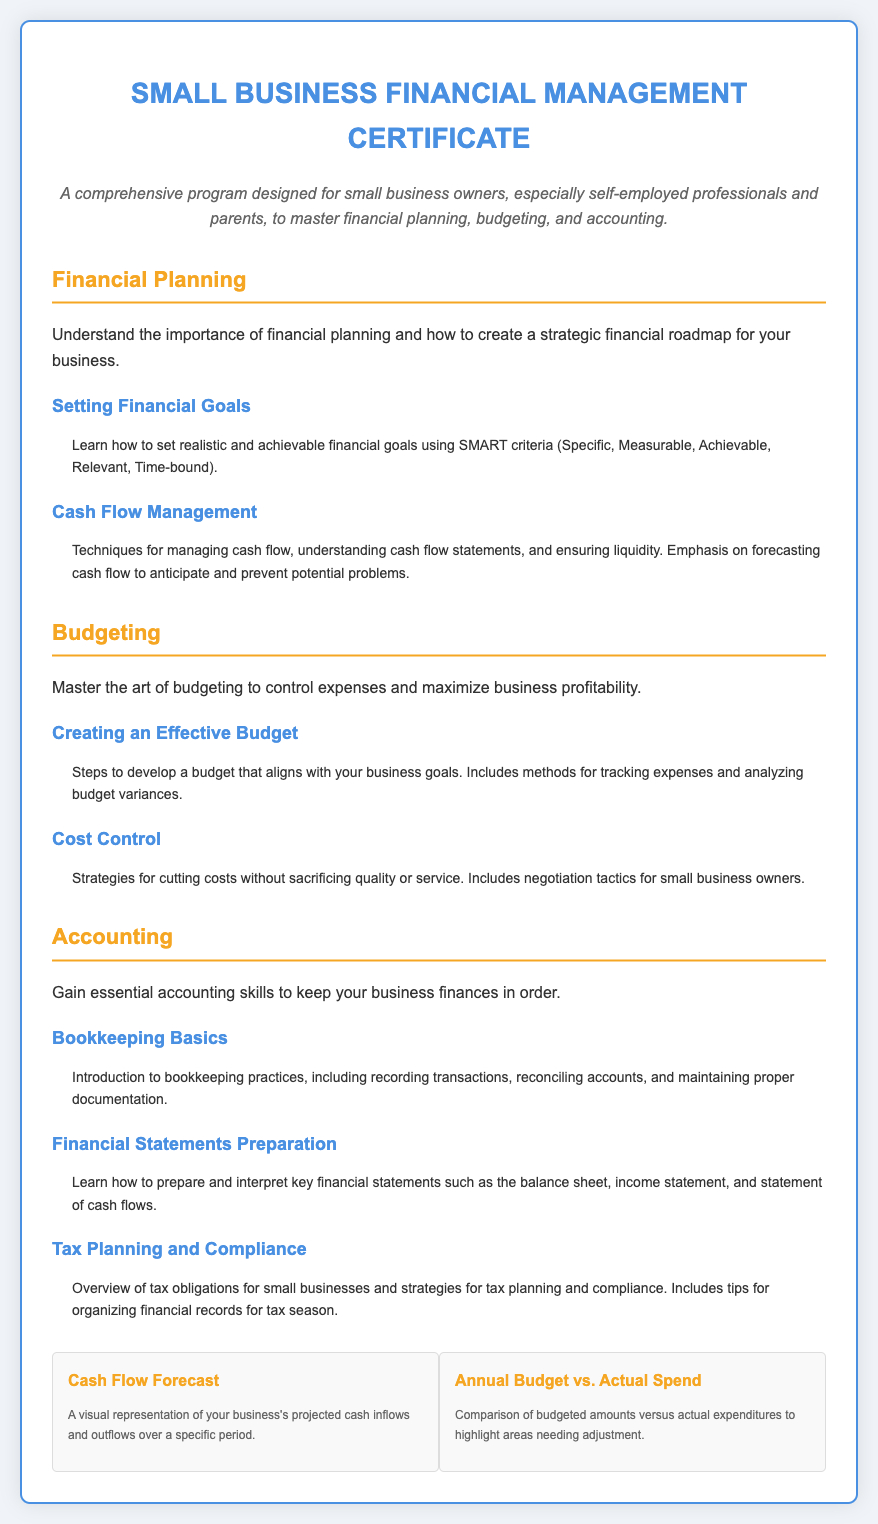what is the title of the certificate? The title of the certificate is prominently displayed at the top of the document.
Answer: Small Business Financial Management Certificate who is the certificate designed for? The description of the certificate specifies its intended audience.
Answer: small business owners what topic is covered under Financial Planning? The sections include specific topics listed under each main area of study.
Answer: Cash Flow Management which budgeting topic focuses on tracking expenses? The curriculum outlines various budgeting techniques and includes this specific focus.
Answer: Creating an Effective Budget how many topics are listed under Accounting? By counting the topics mentioned in the Accounting section, you can determine this number.
Answer: 3 what color is used for section headers? The document uses a consistent color scheme for headers.
Answer: F5A623 what are the two types of graphs included in the document? The graphs presented at the bottom of the certificate provide visual representation of financial concepts.
Answer: Cash Flow Forecast and Annual Budget vs. Actual Spend which financial statement is prepared in the Accounting section? The curriculum includes specific financial statements as part of the learning objectives.
Answer: Income statement what does SMART criteria stand for? SMART is defined in the context of setting financial goals within the document.
Answer: Specific, Measurable, Achievable, Relevant, Time-bound 